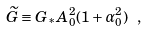Convert formula to latex. <formula><loc_0><loc_0><loc_500><loc_500>\widetilde { G } \equiv G _ { * } A _ { 0 } ^ { 2 } ( 1 + \alpha _ { 0 } ^ { 2 } ) \ ,</formula> 